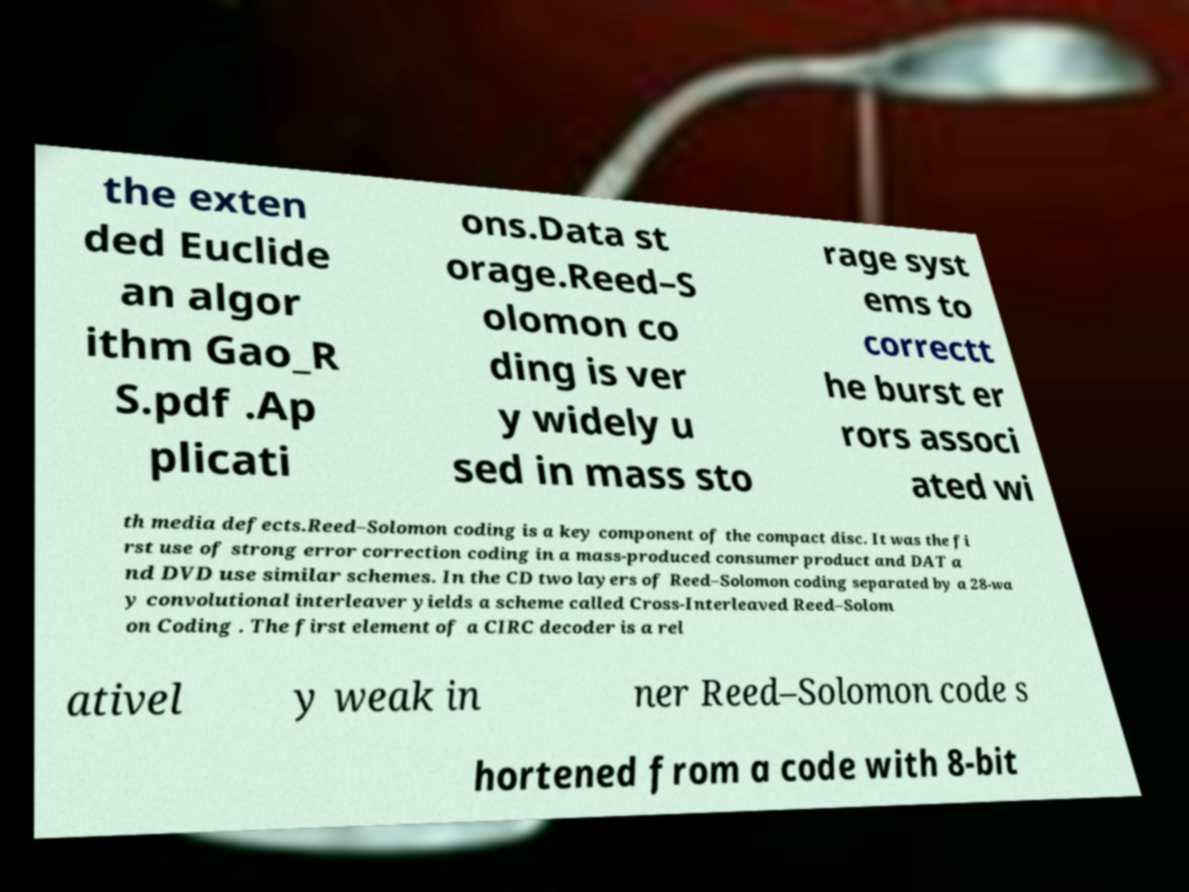For documentation purposes, I need the text within this image transcribed. Could you provide that? the exten ded Euclide an algor ithm Gao_R S.pdf .Ap plicati ons.Data st orage.Reed–S olomon co ding is ver y widely u sed in mass sto rage syst ems to correctt he burst er rors associ ated wi th media defects.Reed–Solomon coding is a key component of the compact disc. It was the fi rst use of strong error correction coding in a mass-produced consumer product and DAT a nd DVD use similar schemes. In the CD two layers of Reed–Solomon coding separated by a 28-wa y convolutional interleaver yields a scheme called Cross-Interleaved Reed–Solom on Coding . The first element of a CIRC decoder is a rel ativel y weak in ner Reed–Solomon code s hortened from a code with 8-bit 